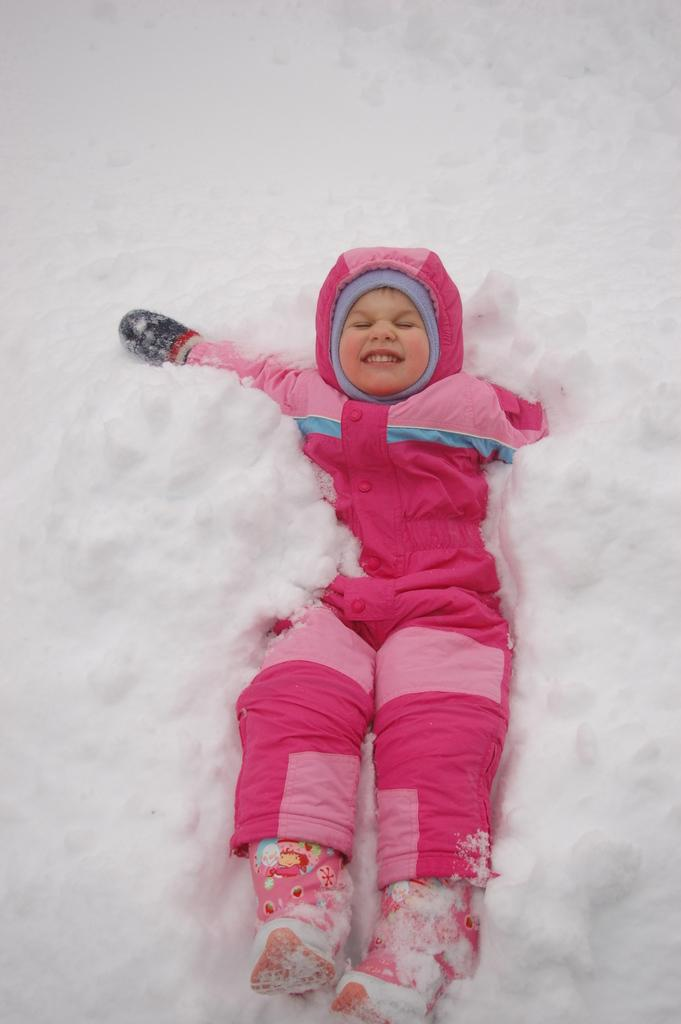What is the main subject of the image? The main subject of the image is a kid. What is the kid doing in the image? The kid is lying on the snow in the image. What type of clothing is the kid wearing to protect against the cold? The kid is wearing a coat, gloves, and shoes in the image. What is the kid's tendency to read books in the library in the image? There is no reference to a library or reading books in the image; the kid is lying on the snow and wearing winter clothing. 